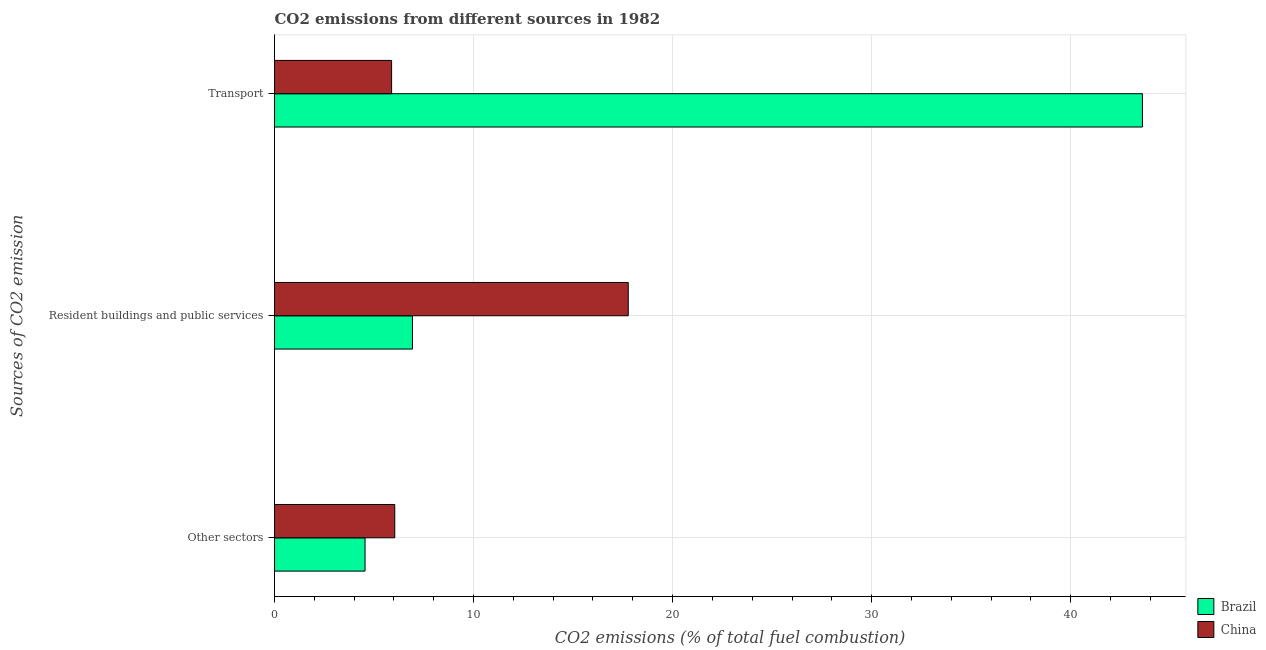How many different coloured bars are there?
Provide a short and direct response. 2. How many groups of bars are there?
Make the answer very short. 3. Are the number of bars per tick equal to the number of legend labels?
Your answer should be very brief. Yes. How many bars are there on the 2nd tick from the bottom?
Offer a very short reply. 2. What is the label of the 2nd group of bars from the top?
Offer a very short reply. Resident buildings and public services. What is the percentage of co2 emissions from transport in Brazil?
Keep it short and to the point. 43.61. Across all countries, what is the maximum percentage of co2 emissions from resident buildings and public services?
Make the answer very short. 17.77. Across all countries, what is the minimum percentage of co2 emissions from other sectors?
Provide a succinct answer. 4.55. What is the total percentage of co2 emissions from transport in the graph?
Your answer should be very brief. 49.49. What is the difference between the percentage of co2 emissions from other sectors in China and that in Brazil?
Your answer should be compact. 1.49. What is the difference between the percentage of co2 emissions from resident buildings and public services in China and the percentage of co2 emissions from transport in Brazil?
Your answer should be compact. -25.84. What is the average percentage of co2 emissions from resident buildings and public services per country?
Keep it short and to the point. 12.35. What is the difference between the percentage of co2 emissions from resident buildings and public services and percentage of co2 emissions from other sectors in Brazil?
Offer a terse response. 2.38. In how many countries, is the percentage of co2 emissions from transport greater than 6 %?
Give a very brief answer. 1. What is the ratio of the percentage of co2 emissions from resident buildings and public services in Brazil to that in China?
Keep it short and to the point. 0.39. Is the percentage of co2 emissions from transport in Brazil less than that in China?
Your response must be concise. No. What is the difference between the highest and the second highest percentage of co2 emissions from resident buildings and public services?
Keep it short and to the point. 10.84. What is the difference between the highest and the lowest percentage of co2 emissions from transport?
Ensure brevity in your answer.  37.73. Is the sum of the percentage of co2 emissions from resident buildings and public services in Brazil and China greater than the maximum percentage of co2 emissions from other sectors across all countries?
Ensure brevity in your answer.  Yes. What does the 1st bar from the top in Transport represents?
Your answer should be very brief. China. How many bars are there?
Offer a very short reply. 6. How many countries are there in the graph?
Offer a very short reply. 2. What is the difference between two consecutive major ticks on the X-axis?
Ensure brevity in your answer.  10. Are the values on the major ticks of X-axis written in scientific E-notation?
Ensure brevity in your answer.  No. Does the graph contain grids?
Your answer should be compact. Yes. How are the legend labels stacked?
Offer a terse response. Vertical. What is the title of the graph?
Offer a terse response. CO2 emissions from different sources in 1982. What is the label or title of the X-axis?
Offer a terse response. CO2 emissions (% of total fuel combustion). What is the label or title of the Y-axis?
Offer a terse response. Sources of CO2 emission. What is the CO2 emissions (% of total fuel combustion) of Brazil in Other sectors?
Your answer should be compact. 4.55. What is the CO2 emissions (% of total fuel combustion) in China in Other sectors?
Keep it short and to the point. 6.04. What is the CO2 emissions (% of total fuel combustion) in Brazil in Resident buildings and public services?
Your response must be concise. 6.93. What is the CO2 emissions (% of total fuel combustion) of China in Resident buildings and public services?
Provide a succinct answer. 17.77. What is the CO2 emissions (% of total fuel combustion) of Brazil in Transport?
Your answer should be very brief. 43.61. What is the CO2 emissions (% of total fuel combustion) in China in Transport?
Provide a short and direct response. 5.88. Across all Sources of CO2 emission, what is the maximum CO2 emissions (% of total fuel combustion) of Brazil?
Ensure brevity in your answer.  43.61. Across all Sources of CO2 emission, what is the maximum CO2 emissions (% of total fuel combustion) of China?
Provide a succinct answer. 17.77. Across all Sources of CO2 emission, what is the minimum CO2 emissions (% of total fuel combustion) in Brazil?
Your answer should be very brief. 4.55. Across all Sources of CO2 emission, what is the minimum CO2 emissions (% of total fuel combustion) of China?
Your answer should be compact. 5.88. What is the total CO2 emissions (% of total fuel combustion) of Brazil in the graph?
Provide a succinct answer. 55.09. What is the total CO2 emissions (% of total fuel combustion) of China in the graph?
Provide a short and direct response. 29.7. What is the difference between the CO2 emissions (% of total fuel combustion) in Brazil in Other sectors and that in Resident buildings and public services?
Keep it short and to the point. -2.38. What is the difference between the CO2 emissions (% of total fuel combustion) of China in Other sectors and that in Resident buildings and public services?
Give a very brief answer. -11.73. What is the difference between the CO2 emissions (% of total fuel combustion) in Brazil in Other sectors and that in Transport?
Your response must be concise. -39.06. What is the difference between the CO2 emissions (% of total fuel combustion) of China in Other sectors and that in Transport?
Ensure brevity in your answer.  0.16. What is the difference between the CO2 emissions (% of total fuel combustion) of Brazil in Resident buildings and public services and that in Transport?
Your answer should be compact. -36.68. What is the difference between the CO2 emissions (% of total fuel combustion) in China in Resident buildings and public services and that in Transport?
Offer a very short reply. 11.89. What is the difference between the CO2 emissions (% of total fuel combustion) in Brazil in Other sectors and the CO2 emissions (% of total fuel combustion) in China in Resident buildings and public services?
Provide a succinct answer. -13.23. What is the difference between the CO2 emissions (% of total fuel combustion) in Brazil in Other sectors and the CO2 emissions (% of total fuel combustion) in China in Transport?
Ensure brevity in your answer.  -1.33. What is the difference between the CO2 emissions (% of total fuel combustion) of Brazil in Resident buildings and public services and the CO2 emissions (% of total fuel combustion) of China in Transport?
Keep it short and to the point. 1.05. What is the average CO2 emissions (% of total fuel combustion) of Brazil per Sources of CO2 emission?
Offer a very short reply. 18.36. What is the average CO2 emissions (% of total fuel combustion) in China per Sources of CO2 emission?
Give a very brief answer. 9.9. What is the difference between the CO2 emissions (% of total fuel combustion) in Brazil and CO2 emissions (% of total fuel combustion) in China in Other sectors?
Give a very brief answer. -1.49. What is the difference between the CO2 emissions (% of total fuel combustion) in Brazil and CO2 emissions (% of total fuel combustion) in China in Resident buildings and public services?
Keep it short and to the point. -10.84. What is the difference between the CO2 emissions (% of total fuel combustion) of Brazil and CO2 emissions (% of total fuel combustion) of China in Transport?
Give a very brief answer. 37.73. What is the ratio of the CO2 emissions (% of total fuel combustion) in Brazil in Other sectors to that in Resident buildings and public services?
Provide a succinct answer. 0.66. What is the ratio of the CO2 emissions (% of total fuel combustion) of China in Other sectors to that in Resident buildings and public services?
Keep it short and to the point. 0.34. What is the ratio of the CO2 emissions (% of total fuel combustion) of Brazil in Other sectors to that in Transport?
Keep it short and to the point. 0.1. What is the ratio of the CO2 emissions (% of total fuel combustion) in China in Other sectors to that in Transport?
Offer a very short reply. 1.03. What is the ratio of the CO2 emissions (% of total fuel combustion) in Brazil in Resident buildings and public services to that in Transport?
Give a very brief answer. 0.16. What is the ratio of the CO2 emissions (% of total fuel combustion) in China in Resident buildings and public services to that in Transport?
Keep it short and to the point. 3.02. What is the difference between the highest and the second highest CO2 emissions (% of total fuel combustion) in Brazil?
Provide a short and direct response. 36.68. What is the difference between the highest and the second highest CO2 emissions (% of total fuel combustion) in China?
Offer a very short reply. 11.73. What is the difference between the highest and the lowest CO2 emissions (% of total fuel combustion) in Brazil?
Keep it short and to the point. 39.06. What is the difference between the highest and the lowest CO2 emissions (% of total fuel combustion) in China?
Provide a succinct answer. 11.89. 